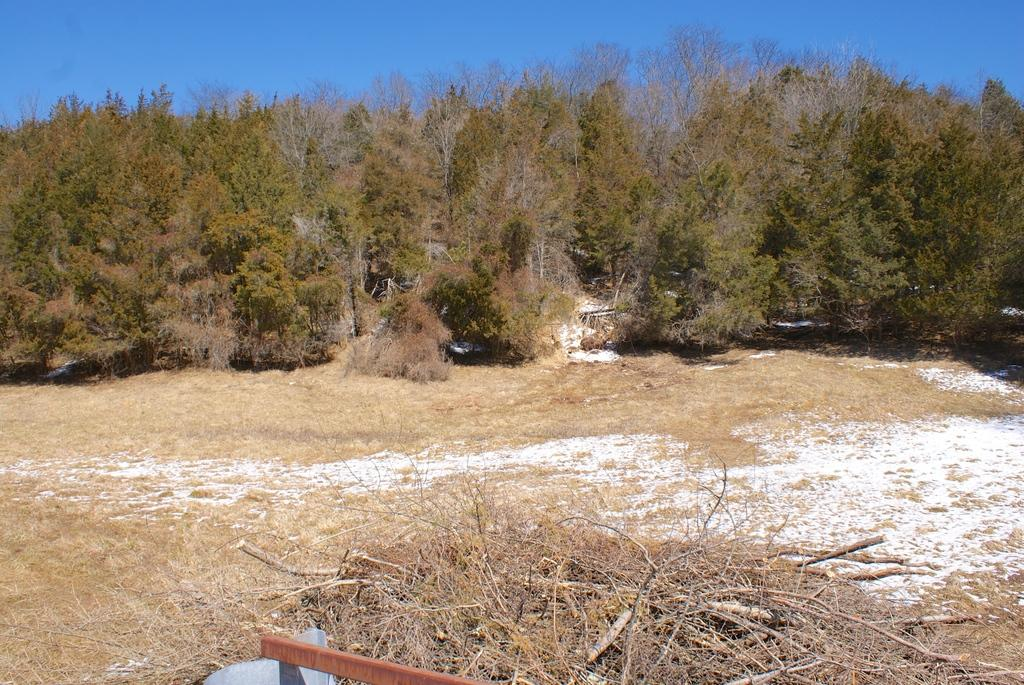What is in the foreground of the picture? Dry grass, twigs, an iron object, and soil are present in the foreground of the picture. What can be seen in the center of the picture? There are trees and shrubs in the center of the picture. What is the condition of the sky in the picture? The sky is sunny in the picture. Can you tell me how many cattle are grazing in the picture? There are no cattle present in the picture; it features dry grass, twigs, an iron object, soil, trees, shrubs, and a sunny sky. What type of bucket is being used to collect water from the trees? There is no bucket present in the picture. 